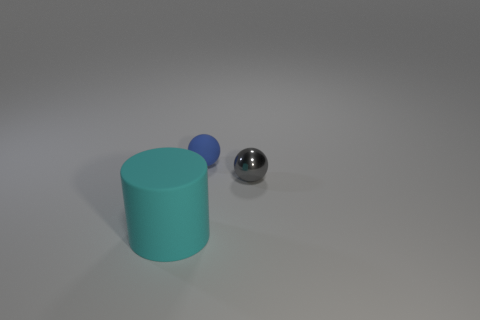What number of large cyan objects are to the right of the big cyan cylinder in front of the matte object to the right of the cyan rubber cylinder?
Keep it short and to the point. 0. There is a matte thing that is to the right of the matte thing that is in front of the gray shiny object; what color is it?
Make the answer very short. Blue. Are there any green cubes of the same size as the cyan matte cylinder?
Your answer should be compact. No. The tiny object that is in front of the matte object behind the rubber thing in front of the metallic sphere is made of what material?
Your answer should be compact. Metal. There is a object that is behind the metallic thing; how many things are to the left of it?
Keep it short and to the point. 1. There is a ball behind the shiny ball; is its size the same as the large cyan matte cylinder?
Give a very brief answer. No. How many cyan metal objects are the same shape as the small rubber thing?
Your answer should be very brief. 0. What is the shape of the big object?
Keep it short and to the point. Cylinder. Are there the same number of blue things that are to the left of the big rubber thing and large yellow rubber cubes?
Provide a succinct answer. Yes. Are there any other things that have the same material as the small gray ball?
Offer a very short reply. No. 